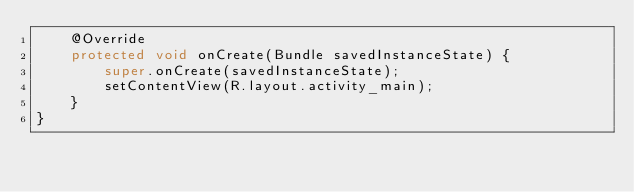Convert code to text. <code><loc_0><loc_0><loc_500><loc_500><_Java_>    @Override
    protected void onCreate(Bundle savedInstanceState) {
        super.onCreate(savedInstanceState);
        setContentView(R.layout.activity_main);
    }
}
</code> 